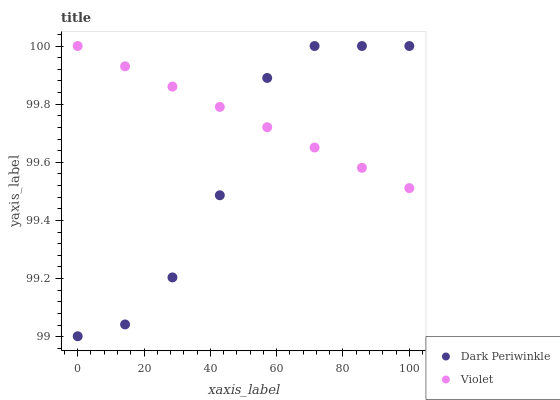Does Dark Periwinkle have the minimum area under the curve?
Answer yes or no. Yes. Does Violet have the maximum area under the curve?
Answer yes or no. Yes. Does Violet have the minimum area under the curve?
Answer yes or no. No. Is Violet the smoothest?
Answer yes or no. Yes. Is Dark Periwinkle the roughest?
Answer yes or no. Yes. Is Violet the roughest?
Answer yes or no. No. Does Dark Periwinkle have the lowest value?
Answer yes or no. Yes. Does Violet have the lowest value?
Answer yes or no. No. Does Violet have the highest value?
Answer yes or no. Yes. Does Violet intersect Dark Periwinkle?
Answer yes or no. Yes. Is Violet less than Dark Periwinkle?
Answer yes or no. No. Is Violet greater than Dark Periwinkle?
Answer yes or no. No. 